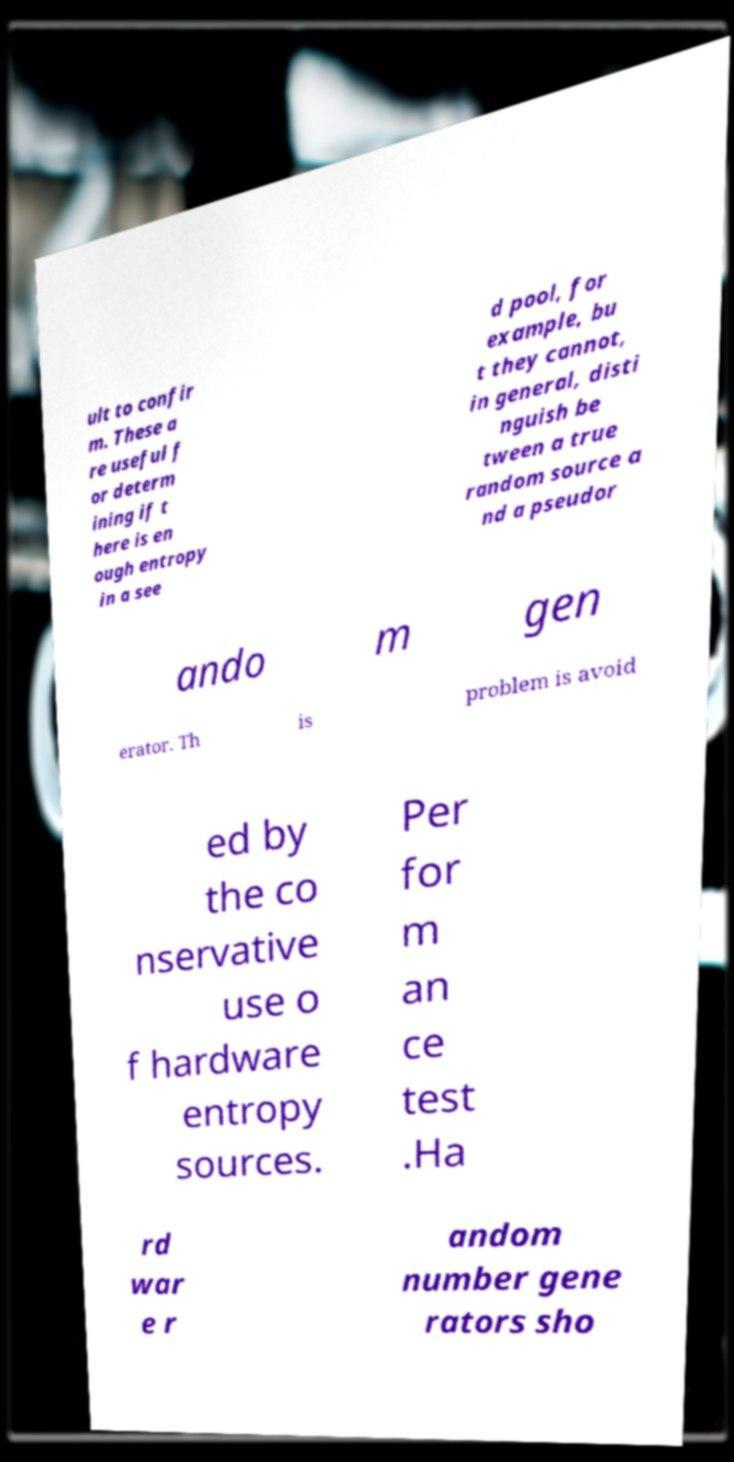What messages or text are displayed in this image? I need them in a readable, typed format. ult to confir m. These a re useful f or determ ining if t here is en ough entropy in a see d pool, for example, bu t they cannot, in general, disti nguish be tween a true random source a nd a pseudor ando m gen erator. Th is problem is avoid ed by the co nservative use o f hardware entropy sources. Per for m an ce test .Ha rd war e r andom number gene rators sho 